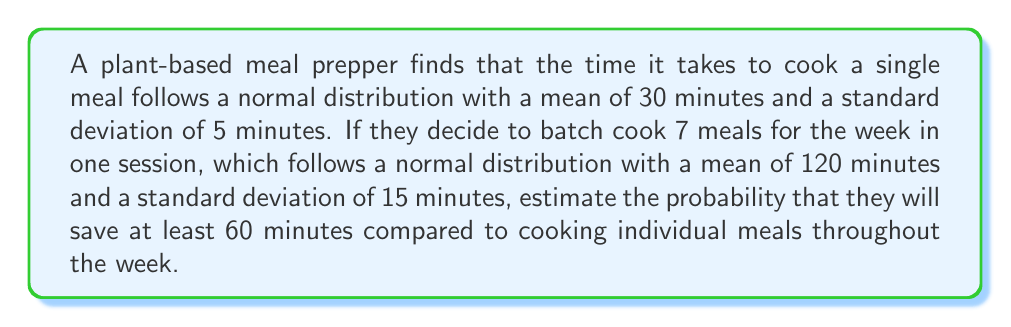Can you answer this question? Let's approach this step-by-step:

1) First, let's define our random variables:
   $X$: Time to cook 7 individual meals
   $Y$: Time to batch cook 7 meals

2) For individual meals:
   $X \sim N(\mu_X = 7 \cdot 30 = 210, \sigma_X = \sqrt{7} \cdot 5 = 13.23)$

3) For batch cooking:
   $Y \sim N(\mu_Y = 120, \sigma_Y = 15)$

4) We want to find $P(X - Y \geq 60)$

5) Let $Z = X - Y$. Since $X$ and $Y$ are independent normal variables, $Z$ is also normal with:
   $\mu_Z = \mu_X - \mu_Y = 210 - 120 = 90$
   $\sigma_Z = \sqrt{\sigma_X^2 + \sigma_Y^2} = \sqrt{13.23^2 + 15^2} = 20$

6) We can standardize this:
   $P(Z \geq 60) = P(\frac{Z - \mu_Z}{\sigma_Z} \geq \frac{60 - 90}{20})$
                 $= P(Z' \geq -1.5)$

7) Using the standard normal table or calculator:
   $P(Z' \geq -1.5) = 1 - P(Z' < -1.5) = 1 - 0.0668 = 0.9332$

Therefore, the probability of saving at least 60 minutes is approximately 0.9332 or 93.32%.
Answer: 0.9332 